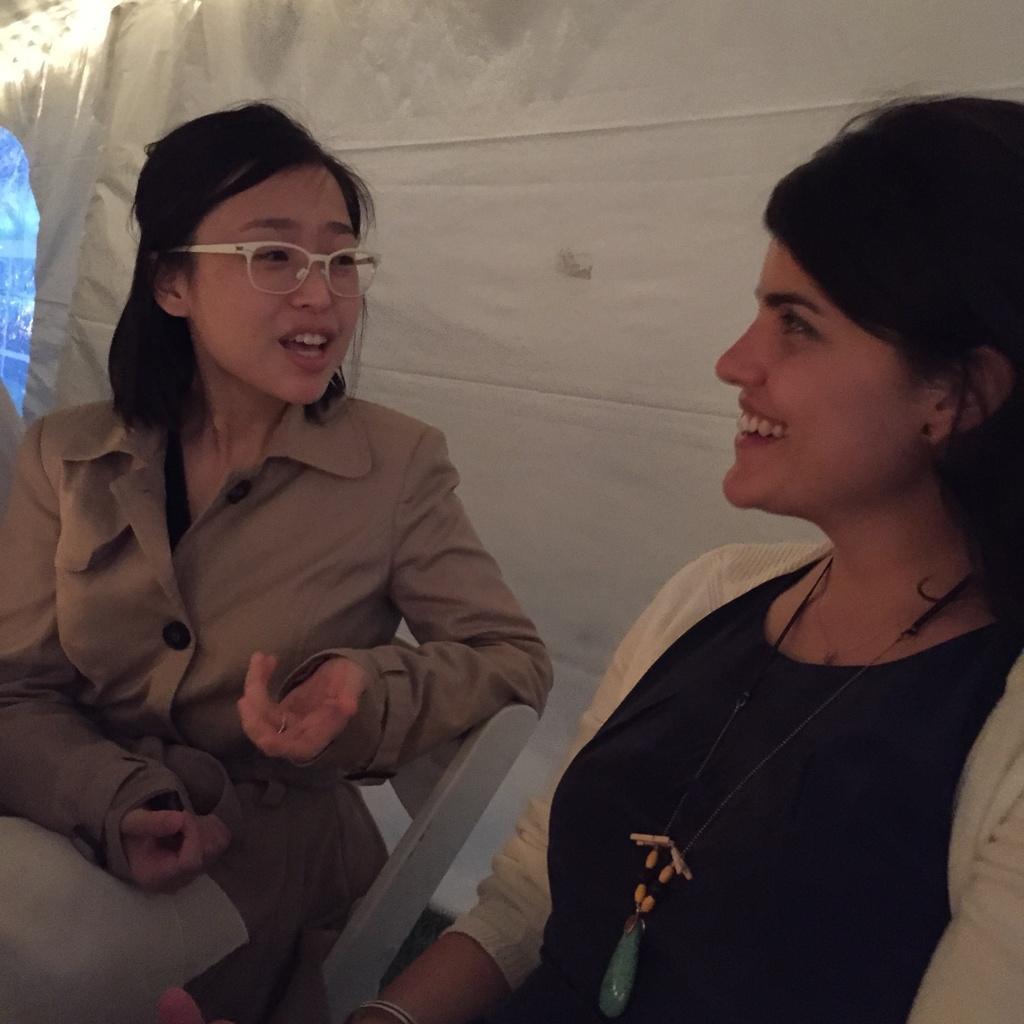Describe this image in one or two sentences. In the image we can see two women sitting, wearing clothes and it looks like they are talking to each other. The left side woman is wearing spectacles and the right side woman is wearing a neck chain. 